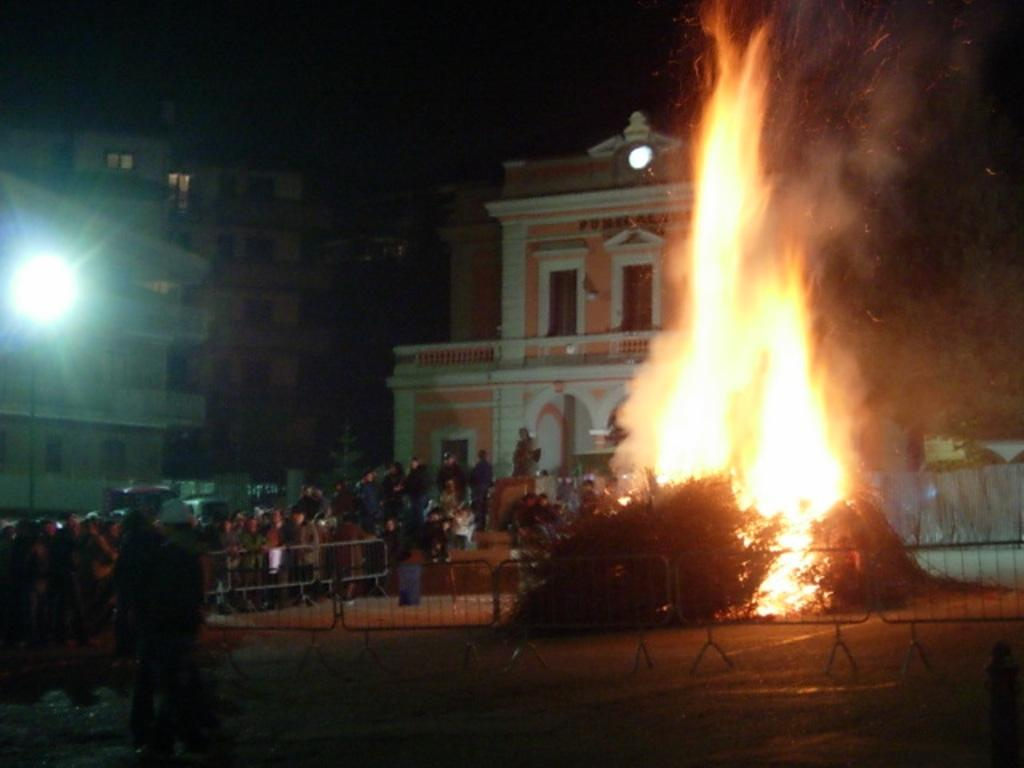How many people are in the image? There are people in the image, but the exact number is not specified. What is the fence used for in the image? The purpose of the fence in the image is not clear, but it is likely serving as a barrier or boundary. What is the source of the fire in the image? The source of the fire in the image is not specified, but it could be a controlled fire or a part of a larger scene. What is the pole used for in the image? The purpose of the pole in the image is not clear, but it could be a support structure or a part of a larger scene. What is the function of the light in the image? The function of the light in the image is not specified, but it could be providing illumination or a part of a larger scene. What type of structures can be seen in the image? There are buildings in the image, but their specific types or functions are not specified. What is the background of the image suggests about the scene? The dark background of the image suggests that the scene may be taking place at night or in a dimly lit area. How many stamps are on the people in the image? There are no stamps visible on the people in the image. What type of ray can be seen swimming in the background of the image? There is no ray present in the image; the background is dark and does not show any aquatic life. 